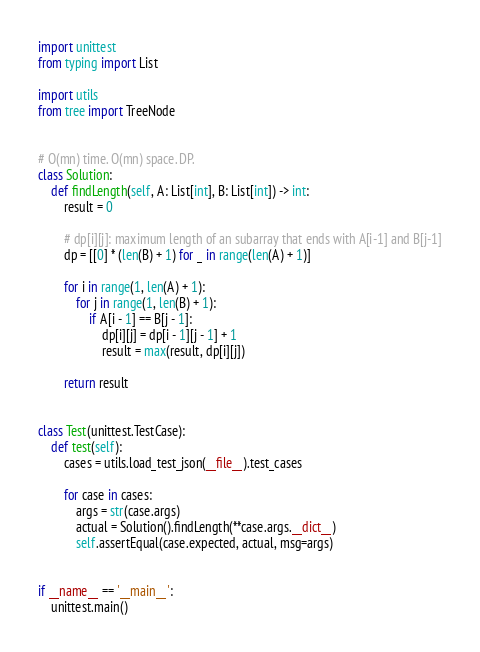Convert code to text. <code><loc_0><loc_0><loc_500><loc_500><_Python_>import unittest
from typing import List

import utils
from tree import TreeNode


# O(mn) time. O(mn) space. DP.
class Solution:
    def findLength(self, A: List[int], B: List[int]) -> int:
        result = 0

        # dp[i][j]: maximum length of an subarray that ends with A[i-1] and B[j-1]
        dp = [[0] * (len(B) + 1) for _ in range(len(A) + 1)]

        for i in range(1, len(A) + 1):
            for j in range(1, len(B) + 1):
                if A[i - 1] == B[j - 1]:
                    dp[i][j] = dp[i - 1][j - 1] + 1
                    result = max(result, dp[i][j])

        return result


class Test(unittest.TestCase):
    def test(self):
        cases = utils.load_test_json(__file__).test_cases

        for case in cases:
            args = str(case.args)
            actual = Solution().findLength(**case.args.__dict__)
            self.assertEqual(case.expected, actual, msg=args)


if __name__ == '__main__':
    unittest.main()
</code> 